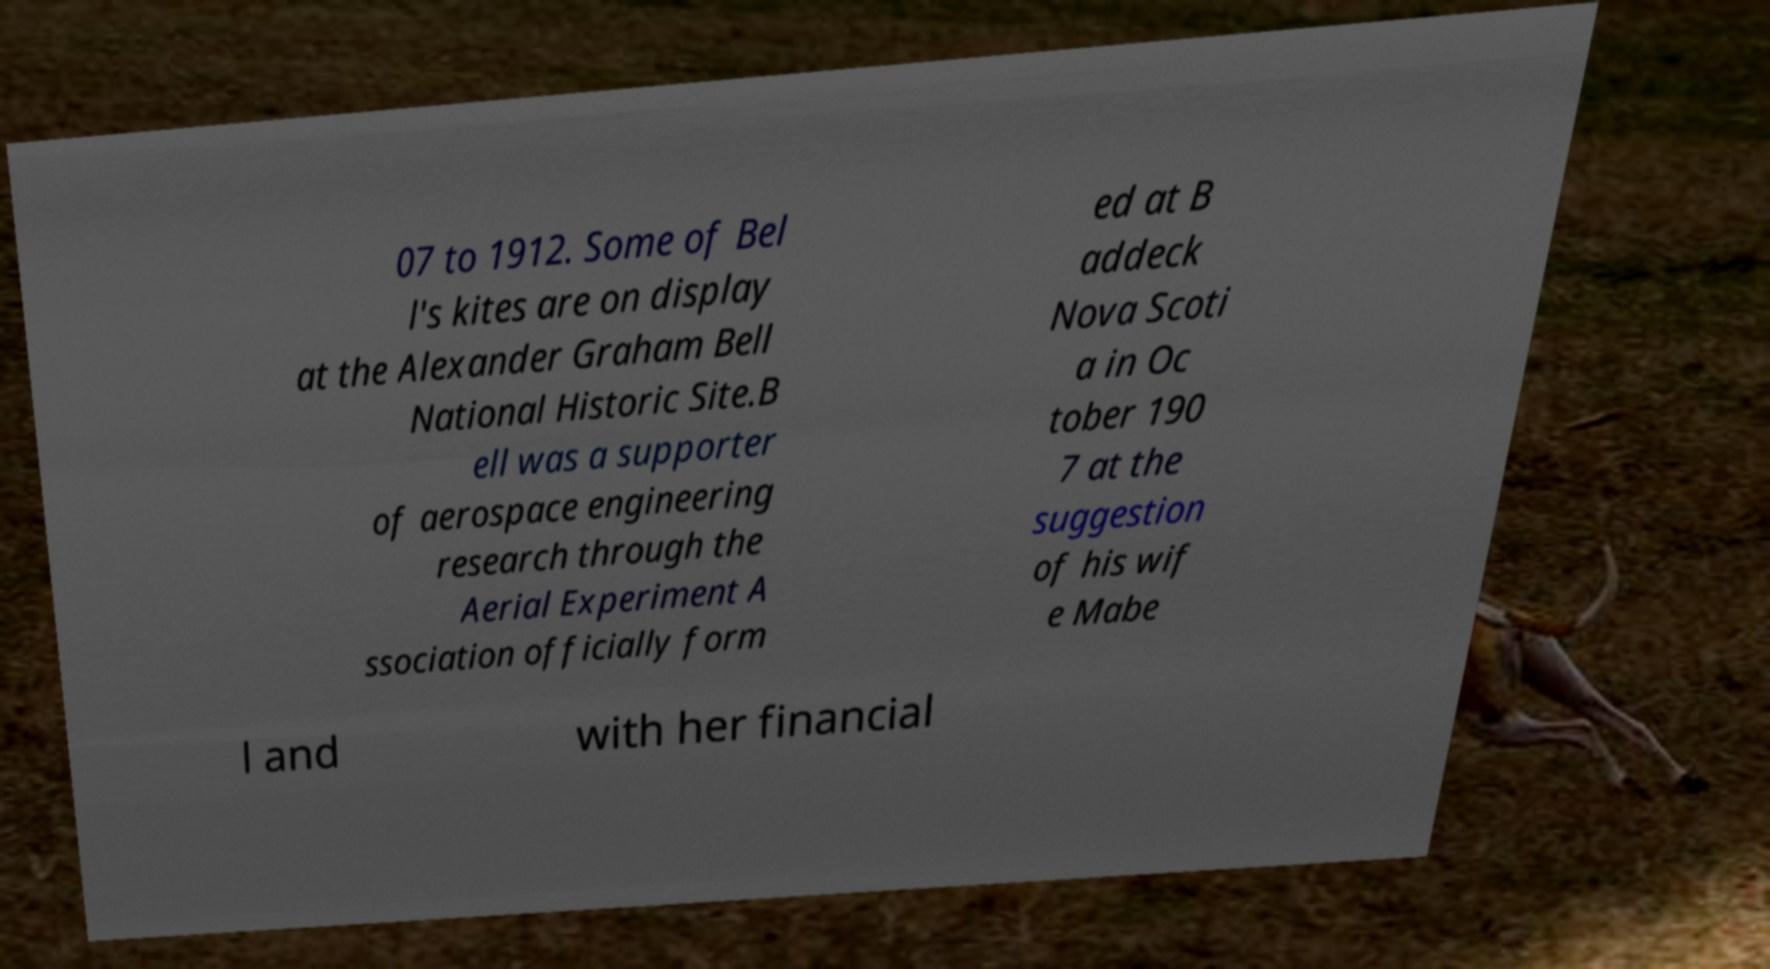I need the written content from this picture converted into text. Can you do that? 07 to 1912. Some of Bel l's kites are on display at the Alexander Graham Bell National Historic Site.B ell was a supporter of aerospace engineering research through the Aerial Experiment A ssociation officially form ed at B addeck Nova Scoti a in Oc tober 190 7 at the suggestion of his wif e Mabe l and with her financial 